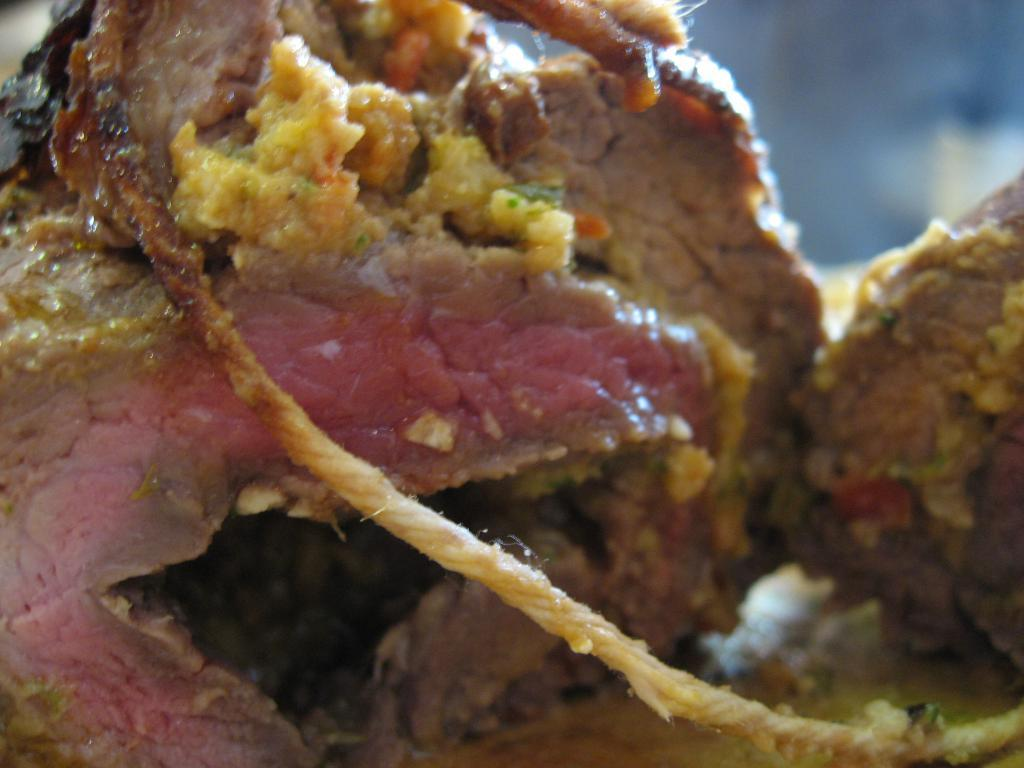What type of food can be seen in the image? There is meat in the image. What other object is present in the image besides the meat? There is a thread in the image. Are there any ants crawling on the meat in the image? There is no mention of ants in the provided facts, so we cannot determine if there are any ants present in the image. 